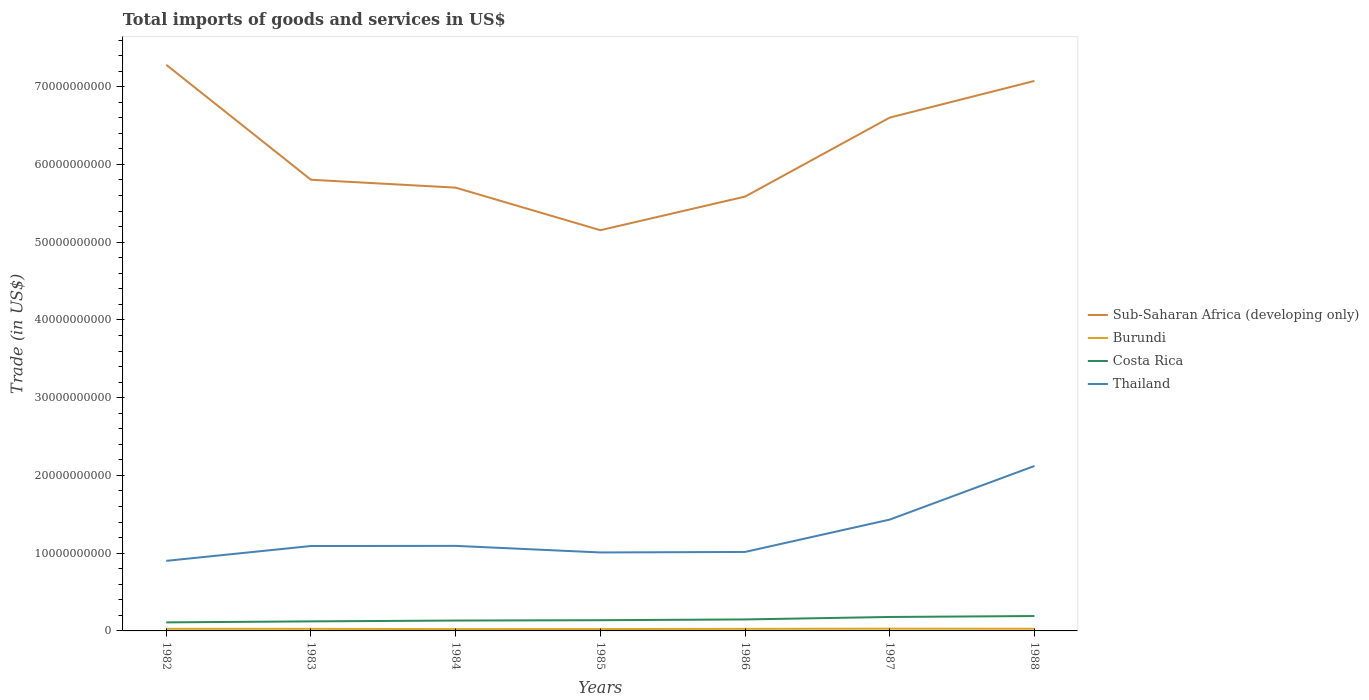How many different coloured lines are there?
Offer a terse response. 4. Is the number of lines equal to the number of legend labels?
Make the answer very short. Yes. Across all years, what is the maximum total imports of goods and services in Sub-Saharan Africa (developing only)?
Your answer should be compact. 5.15e+1. What is the total total imports of goods and services in Thailand in the graph?
Give a very brief answer. -4.23e+09. What is the difference between the highest and the second highest total imports of goods and services in Sub-Saharan Africa (developing only)?
Offer a very short reply. 2.13e+1. How many years are there in the graph?
Offer a terse response. 7. Does the graph contain grids?
Offer a very short reply. No. Where does the legend appear in the graph?
Keep it short and to the point. Center right. How are the legend labels stacked?
Your answer should be compact. Vertical. What is the title of the graph?
Give a very brief answer. Total imports of goods and services in US$. What is the label or title of the Y-axis?
Make the answer very short. Trade (in US$). What is the Trade (in US$) in Sub-Saharan Africa (developing only) in 1982?
Your response must be concise. 7.28e+1. What is the Trade (in US$) in Burundi in 1982?
Keep it short and to the point. 2.73e+08. What is the Trade (in US$) of Costa Rica in 1982?
Your answer should be compact. 1.10e+09. What is the Trade (in US$) of Thailand in 1982?
Your answer should be very brief. 9.01e+09. What is the Trade (in US$) of Sub-Saharan Africa (developing only) in 1983?
Provide a succinct answer. 5.80e+1. What is the Trade (in US$) in Burundi in 1983?
Your response must be concise. 2.68e+08. What is the Trade (in US$) in Costa Rica in 1983?
Provide a short and direct response. 1.23e+09. What is the Trade (in US$) in Thailand in 1983?
Offer a very short reply. 1.09e+1. What is the Trade (in US$) of Sub-Saharan Africa (developing only) in 1984?
Provide a short and direct response. 5.70e+1. What is the Trade (in US$) of Burundi in 1984?
Provide a succinct answer. 2.32e+08. What is the Trade (in US$) in Costa Rica in 1984?
Provide a short and direct response. 1.33e+09. What is the Trade (in US$) in Thailand in 1984?
Your response must be concise. 1.09e+1. What is the Trade (in US$) in Sub-Saharan Africa (developing only) in 1985?
Your answer should be very brief. 5.15e+1. What is the Trade (in US$) of Burundi in 1985?
Provide a succinct answer. 2.39e+08. What is the Trade (in US$) of Costa Rica in 1985?
Provide a short and direct response. 1.38e+09. What is the Trade (in US$) of Thailand in 1985?
Your answer should be compact. 1.01e+1. What is the Trade (in US$) of Sub-Saharan Africa (developing only) in 1986?
Your response must be concise. 5.59e+1. What is the Trade (in US$) in Burundi in 1986?
Keep it short and to the point. 2.68e+08. What is the Trade (in US$) of Costa Rica in 1986?
Offer a terse response. 1.48e+09. What is the Trade (in US$) of Thailand in 1986?
Offer a terse response. 1.02e+1. What is the Trade (in US$) of Sub-Saharan Africa (developing only) in 1987?
Keep it short and to the point. 6.60e+1. What is the Trade (in US$) in Burundi in 1987?
Your answer should be very brief. 2.91e+08. What is the Trade (in US$) of Costa Rica in 1987?
Your response must be concise. 1.80e+09. What is the Trade (in US$) in Thailand in 1987?
Keep it short and to the point. 1.43e+1. What is the Trade (in US$) in Sub-Saharan Africa (developing only) in 1988?
Keep it short and to the point. 7.07e+1. What is the Trade (in US$) of Burundi in 1988?
Offer a terse response. 2.81e+08. What is the Trade (in US$) in Costa Rica in 1988?
Your answer should be compact. 1.91e+09. What is the Trade (in US$) in Thailand in 1988?
Ensure brevity in your answer.  2.12e+1. Across all years, what is the maximum Trade (in US$) in Sub-Saharan Africa (developing only)?
Offer a very short reply. 7.28e+1. Across all years, what is the maximum Trade (in US$) in Burundi?
Offer a terse response. 2.91e+08. Across all years, what is the maximum Trade (in US$) in Costa Rica?
Your response must be concise. 1.91e+09. Across all years, what is the maximum Trade (in US$) of Thailand?
Offer a very short reply. 2.12e+1. Across all years, what is the minimum Trade (in US$) in Sub-Saharan Africa (developing only)?
Give a very brief answer. 5.15e+1. Across all years, what is the minimum Trade (in US$) in Burundi?
Offer a very short reply. 2.32e+08. Across all years, what is the minimum Trade (in US$) of Costa Rica?
Offer a very short reply. 1.10e+09. Across all years, what is the minimum Trade (in US$) of Thailand?
Your answer should be very brief. 9.01e+09. What is the total Trade (in US$) of Sub-Saharan Africa (developing only) in the graph?
Keep it short and to the point. 4.32e+11. What is the total Trade (in US$) in Burundi in the graph?
Ensure brevity in your answer.  1.85e+09. What is the total Trade (in US$) of Costa Rica in the graph?
Give a very brief answer. 1.02e+1. What is the total Trade (in US$) of Thailand in the graph?
Offer a very short reply. 8.67e+1. What is the difference between the Trade (in US$) in Sub-Saharan Africa (developing only) in 1982 and that in 1983?
Ensure brevity in your answer.  1.48e+1. What is the difference between the Trade (in US$) of Burundi in 1982 and that in 1983?
Give a very brief answer. 4.63e+06. What is the difference between the Trade (in US$) in Costa Rica in 1982 and that in 1983?
Provide a succinct answer. -1.28e+08. What is the difference between the Trade (in US$) of Thailand in 1982 and that in 1983?
Make the answer very short. -1.91e+09. What is the difference between the Trade (in US$) in Sub-Saharan Africa (developing only) in 1982 and that in 1984?
Your answer should be compact. 1.58e+1. What is the difference between the Trade (in US$) in Burundi in 1982 and that in 1984?
Keep it short and to the point. 4.01e+07. What is the difference between the Trade (in US$) in Costa Rica in 1982 and that in 1984?
Provide a short and direct response. -2.35e+08. What is the difference between the Trade (in US$) of Thailand in 1982 and that in 1984?
Give a very brief answer. -1.93e+09. What is the difference between the Trade (in US$) in Sub-Saharan Africa (developing only) in 1982 and that in 1985?
Provide a short and direct response. 2.13e+1. What is the difference between the Trade (in US$) in Burundi in 1982 and that in 1985?
Ensure brevity in your answer.  3.36e+07. What is the difference between the Trade (in US$) of Costa Rica in 1982 and that in 1985?
Your response must be concise. -2.79e+08. What is the difference between the Trade (in US$) of Thailand in 1982 and that in 1985?
Your answer should be compact. -1.08e+09. What is the difference between the Trade (in US$) in Sub-Saharan Africa (developing only) in 1982 and that in 1986?
Offer a terse response. 1.70e+1. What is the difference between the Trade (in US$) of Burundi in 1982 and that in 1986?
Offer a terse response. 4.46e+06. What is the difference between the Trade (in US$) in Costa Rica in 1982 and that in 1986?
Offer a terse response. -3.77e+08. What is the difference between the Trade (in US$) in Thailand in 1982 and that in 1986?
Your response must be concise. -1.15e+09. What is the difference between the Trade (in US$) in Sub-Saharan Africa (developing only) in 1982 and that in 1987?
Provide a short and direct response. 6.79e+09. What is the difference between the Trade (in US$) in Burundi in 1982 and that in 1987?
Your answer should be very brief. -1.86e+07. What is the difference between the Trade (in US$) in Costa Rica in 1982 and that in 1987?
Offer a very short reply. -6.96e+08. What is the difference between the Trade (in US$) of Thailand in 1982 and that in 1987?
Keep it short and to the point. -5.31e+09. What is the difference between the Trade (in US$) of Sub-Saharan Africa (developing only) in 1982 and that in 1988?
Your answer should be very brief. 2.08e+09. What is the difference between the Trade (in US$) of Burundi in 1982 and that in 1988?
Your answer should be compact. -8.29e+06. What is the difference between the Trade (in US$) of Costa Rica in 1982 and that in 1988?
Give a very brief answer. -8.15e+08. What is the difference between the Trade (in US$) in Thailand in 1982 and that in 1988?
Your answer should be very brief. -1.22e+1. What is the difference between the Trade (in US$) in Sub-Saharan Africa (developing only) in 1983 and that in 1984?
Ensure brevity in your answer.  1.01e+09. What is the difference between the Trade (in US$) of Burundi in 1983 and that in 1984?
Your answer should be very brief. 3.55e+07. What is the difference between the Trade (in US$) in Costa Rica in 1983 and that in 1984?
Your answer should be very brief. -1.07e+08. What is the difference between the Trade (in US$) of Thailand in 1983 and that in 1984?
Keep it short and to the point. -1.66e+07. What is the difference between the Trade (in US$) of Sub-Saharan Africa (developing only) in 1983 and that in 1985?
Ensure brevity in your answer.  6.49e+09. What is the difference between the Trade (in US$) of Burundi in 1983 and that in 1985?
Keep it short and to the point. 2.90e+07. What is the difference between the Trade (in US$) in Costa Rica in 1983 and that in 1985?
Your response must be concise. -1.51e+08. What is the difference between the Trade (in US$) in Thailand in 1983 and that in 1985?
Give a very brief answer. 8.30e+08. What is the difference between the Trade (in US$) in Sub-Saharan Africa (developing only) in 1983 and that in 1986?
Your answer should be compact. 2.17e+09. What is the difference between the Trade (in US$) in Burundi in 1983 and that in 1986?
Offer a very short reply. -1.73e+05. What is the difference between the Trade (in US$) of Costa Rica in 1983 and that in 1986?
Provide a succinct answer. -2.50e+08. What is the difference between the Trade (in US$) in Thailand in 1983 and that in 1986?
Give a very brief answer. 7.63e+08. What is the difference between the Trade (in US$) of Sub-Saharan Africa (developing only) in 1983 and that in 1987?
Provide a short and direct response. -7.99e+09. What is the difference between the Trade (in US$) in Burundi in 1983 and that in 1987?
Keep it short and to the point. -2.32e+07. What is the difference between the Trade (in US$) in Costa Rica in 1983 and that in 1987?
Your answer should be very brief. -5.68e+08. What is the difference between the Trade (in US$) in Thailand in 1983 and that in 1987?
Keep it short and to the point. -3.40e+09. What is the difference between the Trade (in US$) in Sub-Saharan Africa (developing only) in 1983 and that in 1988?
Your answer should be compact. -1.27e+1. What is the difference between the Trade (in US$) in Burundi in 1983 and that in 1988?
Your response must be concise. -1.29e+07. What is the difference between the Trade (in US$) of Costa Rica in 1983 and that in 1988?
Offer a very short reply. -6.88e+08. What is the difference between the Trade (in US$) in Thailand in 1983 and that in 1988?
Make the answer very short. -1.03e+1. What is the difference between the Trade (in US$) of Sub-Saharan Africa (developing only) in 1984 and that in 1985?
Make the answer very short. 5.47e+09. What is the difference between the Trade (in US$) of Burundi in 1984 and that in 1985?
Offer a terse response. -6.55e+06. What is the difference between the Trade (in US$) in Costa Rica in 1984 and that in 1985?
Your response must be concise. -4.40e+07. What is the difference between the Trade (in US$) of Thailand in 1984 and that in 1985?
Provide a short and direct response. 8.46e+08. What is the difference between the Trade (in US$) of Sub-Saharan Africa (developing only) in 1984 and that in 1986?
Give a very brief answer. 1.15e+09. What is the difference between the Trade (in US$) in Burundi in 1984 and that in 1986?
Ensure brevity in your answer.  -3.57e+07. What is the difference between the Trade (in US$) of Costa Rica in 1984 and that in 1986?
Give a very brief answer. -1.43e+08. What is the difference between the Trade (in US$) of Thailand in 1984 and that in 1986?
Ensure brevity in your answer.  7.80e+08. What is the difference between the Trade (in US$) of Sub-Saharan Africa (developing only) in 1984 and that in 1987?
Your answer should be very brief. -9.01e+09. What is the difference between the Trade (in US$) of Burundi in 1984 and that in 1987?
Ensure brevity in your answer.  -5.87e+07. What is the difference between the Trade (in US$) in Costa Rica in 1984 and that in 1987?
Give a very brief answer. -4.62e+08. What is the difference between the Trade (in US$) of Thailand in 1984 and that in 1987?
Your answer should be compact. -3.38e+09. What is the difference between the Trade (in US$) in Sub-Saharan Africa (developing only) in 1984 and that in 1988?
Your response must be concise. -1.37e+1. What is the difference between the Trade (in US$) in Burundi in 1984 and that in 1988?
Your response must be concise. -4.84e+07. What is the difference between the Trade (in US$) in Costa Rica in 1984 and that in 1988?
Provide a succinct answer. -5.81e+08. What is the difference between the Trade (in US$) in Thailand in 1984 and that in 1988?
Ensure brevity in your answer.  -1.03e+1. What is the difference between the Trade (in US$) in Sub-Saharan Africa (developing only) in 1985 and that in 1986?
Provide a succinct answer. -4.32e+09. What is the difference between the Trade (in US$) of Burundi in 1985 and that in 1986?
Offer a terse response. -2.91e+07. What is the difference between the Trade (in US$) of Costa Rica in 1985 and that in 1986?
Make the answer very short. -9.89e+07. What is the difference between the Trade (in US$) in Thailand in 1985 and that in 1986?
Make the answer very short. -6.60e+07. What is the difference between the Trade (in US$) in Sub-Saharan Africa (developing only) in 1985 and that in 1987?
Your answer should be compact. -1.45e+1. What is the difference between the Trade (in US$) of Burundi in 1985 and that in 1987?
Your answer should be compact. -5.22e+07. What is the difference between the Trade (in US$) in Costa Rica in 1985 and that in 1987?
Offer a terse response. -4.18e+08. What is the difference between the Trade (in US$) of Thailand in 1985 and that in 1987?
Make the answer very short. -4.23e+09. What is the difference between the Trade (in US$) in Sub-Saharan Africa (developing only) in 1985 and that in 1988?
Your response must be concise. -1.92e+1. What is the difference between the Trade (in US$) in Burundi in 1985 and that in 1988?
Your response must be concise. -4.19e+07. What is the difference between the Trade (in US$) in Costa Rica in 1985 and that in 1988?
Your answer should be compact. -5.37e+08. What is the difference between the Trade (in US$) in Thailand in 1985 and that in 1988?
Give a very brief answer. -1.11e+1. What is the difference between the Trade (in US$) of Sub-Saharan Africa (developing only) in 1986 and that in 1987?
Offer a terse response. -1.02e+1. What is the difference between the Trade (in US$) of Burundi in 1986 and that in 1987?
Provide a succinct answer. -2.31e+07. What is the difference between the Trade (in US$) in Costa Rica in 1986 and that in 1987?
Provide a short and direct response. -3.19e+08. What is the difference between the Trade (in US$) of Thailand in 1986 and that in 1987?
Offer a very short reply. -4.16e+09. What is the difference between the Trade (in US$) in Sub-Saharan Africa (developing only) in 1986 and that in 1988?
Provide a short and direct response. -1.49e+1. What is the difference between the Trade (in US$) of Burundi in 1986 and that in 1988?
Your response must be concise. -1.27e+07. What is the difference between the Trade (in US$) of Costa Rica in 1986 and that in 1988?
Offer a very short reply. -4.38e+08. What is the difference between the Trade (in US$) in Thailand in 1986 and that in 1988?
Your response must be concise. -1.11e+1. What is the difference between the Trade (in US$) of Sub-Saharan Africa (developing only) in 1987 and that in 1988?
Your response must be concise. -4.72e+09. What is the difference between the Trade (in US$) in Burundi in 1987 and that in 1988?
Offer a terse response. 1.03e+07. What is the difference between the Trade (in US$) of Costa Rica in 1987 and that in 1988?
Give a very brief answer. -1.19e+08. What is the difference between the Trade (in US$) in Thailand in 1987 and that in 1988?
Keep it short and to the point. -6.90e+09. What is the difference between the Trade (in US$) in Sub-Saharan Africa (developing only) in 1982 and the Trade (in US$) in Burundi in 1983?
Your answer should be compact. 7.25e+1. What is the difference between the Trade (in US$) in Sub-Saharan Africa (developing only) in 1982 and the Trade (in US$) in Costa Rica in 1983?
Provide a succinct answer. 7.16e+1. What is the difference between the Trade (in US$) in Sub-Saharan Africa (developing only) in 1982 and the Trade (in US$) in Thailand in 1983?
Your response must be concise. 6.19e+1. What is the difference between the Trade (in US$) of Burundi in 1982 and the Trade (in US$) of Costa Rica in 1983?
Your answer should be very brief. -9.54e+08. What is the difference between the Trade (in US$) of Burundi in 1982 and the Trade (in US$) of Thailand in 1983?
Offer a terse response. -1.06e+1. What is the difference between the Trade (in US$) in Costa Rica in 1982 and the Trade (in US$) in Thailand in 1983?
Your answer should be compact. -9.82e+09. What is the difference between the Trade (in US$) of Sub-Saharan Africa (developing only) in 1982 and the Trade (in US$) of Burundi in 1984?
Your answer should be compact. 7.26e+1. What is the difference between the Trade (in US$) of Sub-Saharan Africa (developing only) in 1982 and the Trade (in US$) of Costa Rica in 1984?
Your answer should be very brief. 7.15e+1. What is the difference between the Trade (in US$) of Sub-Saharan Africa (developing only) in 1982 and the Trade (in US$) of Thailand in 1984?
Keep it short and to the point. 6.19e+1. What is the difference between the Trade (in US$) in Burundi in 1982 and the Trade (in US$) in Costa Rica in 1984?
Provide a short and direct response. -1.06e+09. What is the difference between the Trade (in US$) of Burundi in 1982 and the Trade (in US$) of Thailand in 1984?
Your answer should be very brief. -1.07e+1. What is the difference between the Trade (in US$) in Costa Rica in 1982 and the Trade (in US$) in Thailand in 1984?
Provide a succinct answer. -9.84e+09. What is the difference between the Trade (in US$) of Sub-Saharan Africa (developing only) in 1982 and the Trade (in US$) of Burundi in 1985?
Make the answer very short. 7.26e+1. What is the difference between the Trade (in US$) in Sub-Saharan Africa (developing only) in 1982 and the Trade (in US$) in Costa Rica in 1985?
Give a very brief answer. 7.14e+1. What is the difference between the Trade (in US$) in Sub-Saharan Africa (developing only) in 1982 and the Trade (in US$) in Thailand in 1985?
Ensure brevity in your answer.  6.27e+1. What is the difference between the Trade (in US$) in Burundi in 1982 and the Trade (in US$) in Costa Rica in 1985?
Offer a very short reply. -1.10e+09. What is the difference between the Trade (in US$) of Burundi in 1982 and the Trade (in US$) of Thailand in 1985?
Offer a terse response. -9.82e+09. What is the difference between the Trade (in US$) of Costa Rica in 1982 and the Trade (in US$) of Thailand in 1985?
Offer a very short reply. -8.99e+09. What is the difference between the Trade (in US$) of Sub-Saharan Africa (developing only) in 1982 and the Trade (in US$) of Burundi in 1986?
Provide a short and direct response. 7.25e+1. What is the difference between the Trade (in US$) of Sub-Saharan Africa (developing only) in 1982 and the Trade (in US$) of Costa Rica in 1986?
Your response must be concise. 7.13e+1. What is the difference between the Trade (in US$) in Sub-Saharan Africa (developing only) in 1982 and the Trade (in US$) in Thailand in 1986?
Offer a very short reply. 6.27e+1. What is the difference between the Trade (in US$) of Burundi in 1982 and the Trade (in US$) of Costa Rica in 1986?
Provide a succinct answer. -1.20e+09. What is the difference between the Trade (in US$) in Burundi in 1982 and the Trade (in US$) in Thailand in 1986?
Give a very brief answer. -9.88e+09. What is the difference between the Trade (in US$) in Costa Rica in 1982 and the Trade (in US$) in Thailand in 1986?
Your answer should be very brief. -9.06e+09. What is the difference between the Trade (in US$) in Sub-Saharan Africa (developing only) in 1982 and the Trade (in US$) in Burundi in 1987?
Your response must be concise. 7.25e+1. What is the difference between the Trade (in US$) in Sub-Saharan Africa (developing only) in 1982 and the Trade (in US$) in Costa Rica in 1987?
Your answer should be very brief. 7.10e+1. What is the difference between the Trade (in US$) in Sub-Saharan Africa (developing only) in 1982 and the Trade (in US$) in Thailand in 1987?
Ensure brevity in your answer.  5.85e+1. What is the difference between the Trade (in US$) in Burundi in 1982 and the Trade (in US$) in Costa Rica in 1987?
Offer a terse response. -1.52e+09. What is the difference between the Trade (in US$) in Burundi in 1982 and the Trade (in US$) in Thailand in 1987?
Your answer should be very brief. -1.40e+1. What is the difference between the Trade (in US$) in Costa Rica in 1982 and the Trade (in US$) in Thailand in 1987?
Offer a terse response. -1.32e+1. What is the difference between the Trade (in US$) in Sub-Saharan Africa (developing only) in 1982 and the Trade (in US$) in Burundi in 1988?
Your answer should be very brief. 7.25e+1. What is the difference between the Trade (in US$) in Sub-Saharan Africa (developing only) in 1982 and the Trade (in US$) in Costa Rica in 1988?
Keep it short and to the point. 7.09e+1. What is the difference between the Trade (in US$) in Sub-Saharan Africa (developing only) in 1982 and the Trade (in US$) in Thailand in 1988?
Offer a very short reply. 5.16e+1. What is the difference between the Trade (in US$) in Burundi in 1982 and the Trade (in US$) in Costa Rica in 1988?
Provide a succinct answer. -1.64e+09. What is the difference between the Trade (in US$) in Burundi in 1982 and the Trade (in US$) in Thailand in 1988?
Give a very brief answer. -2.09e+1. What is the difference between the Trade (in US$) in Costa Rica in 1982 and the Trade (in US$) in Thailand in 1988?
Keep it short and to the point. -2.01e+1. What is the difference between the Trade (in US$) of Sub-Saharan Africa (developing only) in 1983 and the Trade (in US$) of Burundi in 1984?
Your response must be concise. 5.78e+1. What is the difference between the Trade (in US$) of Sub-Saharan Africa (developing only) in 1983 and the Trade (in US$) of Costa Rica in 1984?
Offer a terse response. 5.67e+1. What is the difference between the Trade (in US$) in Sub-Saharan Africa (developing only) in 1983 and the Trade (in US$) in Thailand in 1984?
Give a very brief answer. 4.71e+1. What is the difference between the Trade (in US$) in Burundi in 1983 and the Trade (in US$) in Costa Rica in 1984?
Offer a terse response. -1.07e+09. What is the difference between the Trade (in US$) in Burundi in 1983 and the Trade (in US$) in Thailand in 1984?
Provide a short and direct response. -1.07e+1. What is the difference between the Trade (in US$) of Costa Rica in 1983 and the Trade (in US$) of Thailand in 1984?
Your answer should be very brief. -9.71e+09. What is the difference between the Trade (in US$) of Sub-Saharan Africa (developing only) in 1983 and the Trade (in US$) of Burundi in 1985?
Provide a succinct answer. 5.78e+1. What is the difference between the Trade (in US$) of Sub-Saharan Africa (developing only) in 1983 and the Trade (in US$) of Costa Rica in 1985?
Your response must be concise. 5.66e+1. What is the difference between the Trade (in US$) of Sub-Saharan Africa (developing only) in 1983 and the Trade (in US$) of Thailand in 1985?
Give a very brief answer. 4.79e+1. What is the difference between the Trade (in US$) of Burundi in 1983 and the Trade (in US$) of Costa Rica in 1985?
Give a very brief answer. -1.11e+09. What is the difference between the Trade (in US$) of Burundi in 1983 and the Trade (in US$) of Thailand in 1985?
Provide a short and direct response. -9.82e+09. What is the difference between the Trade (in US$) in Costa Rica in 1983 and the Trade (in US$) in Thailand in 1985?
Your answer should be very brief. -8.86e+09. What is the difference between the Trade (in US$) in Sub-Saharan Africa (developing only) in 1983 and the Trade (in US$) in Burundi in 1986?
Provide a succinct answer. 5.78e+1. What is the difference between the Trade (in US$) in Sub-Saharan Africa (developing only) in 1983 and the Trade (in US$) in Costa Rica in 1986?
Your answer should be very brief. 5.66e+1. What is the difference between the Trade (in US$) of Sub-Saharan Africa (developing only) in 1983 and the Trade (in US$) of Thailand in 1986?
Offer a very short reply. 4.79e+1. What is the difference between the Trade (in US$) in Burundi in 1983 and the Trade (in US$) in Costa Rica in 1986?
Provide a short and direct response. -1.21e+09. What is the difference between the Trade (in US$) of Burundi in 1983 and the Trade (in US$) of Thailand in 1986?
Ensure brevity in your answer.  -9.89e+09. What is the difference between the Trade (in US$) in Costa Rica in 1983 and the Trade (in US$) in Thailand in 1986?
Ensure brevity in your answer.  -8.93e+09. What is the difference between the Trade (in US$) of Sub-Saharan Africa (developing only) in 1983 and the Trade (in US$) of Burundi in 1987?
Provide a short and direct response. 5.77e+1. What is the difference between the Trade (in US$) in Sub-Saharan Africa (developing only) in 1983 and the Trade (in US$) in Costa Rica in 1987?
Offer a terse response. 5.62e+1. What is the difference between the Trade (in US$) in Sub-Saharan Africa (developing only) in 1983 and the Trade (in US$) in Thailand in 1987?
Provide a succinct answer. 4.37e+1. What is the difference between the Trade (in US$) of Burundi in 1983 and the Trade (in US$) of Costa Rica in 1987?
Offer a very short reply. -1.53e+09. What is the difference between the Trade (in US$) of Burundi in 1983 and the Trade (in US$) of Thailand in 1987?
Ensure brevity in your answer.  -1.41e+1. What is the difference between the Trade (in US$) of Costa Rica in 1983 and the Trade (in US$) of Thailand in 1987?
Give a very brief answer. -1.31e+1. What is the difference between the Trade (in US$) of Sub-Saharan Africa (developing only) in 1983 and the Trade (in US$) of Burundi in 1988?
Your answer should be very brief. 5.77e+1. What is the difference between the Trade (in US$) of Sub-Saharan Africa (developing only) in 1983 and the Trade (in US$) of Costa Rica in 1988?
Ensure brevity in your answer.  5.61e+1. What is the difference between the Trade (in US$) of Sub-Saharan Africa (developing only) in 1983 and the Trade (in US$) of Thailand in 1988?
Give a very brief answer. 3.68e+1. What is the difference between the Trade (in US$) of Burundi in 1983 and the Trade (in US$) of Costa Rica in 1988?
Give a very brief answer. -1.65e+09. What is the difference between the Trade (in US$) of Burundi in 1983 and the Trade (in US$) of Thailand in 1988?
Keep it short and to the point. -2.09e+1. What is the difference between the Trade (in US$) in Costa Rica in 1983 and the Trade (in US$) in Thailand in 1988?
Provide a short and direct response. -2.00e+1. What is the difference between the Trade (in US$) in Sub-Saharan Africa (developing only) in 1984 and the Trade (in US$) in Burundi in 1985?
Ensure brevity in your answer.  5.68e+1. What is the difference between the Trade (in US$) in Sub-Saharan Africa (developing only) in 1984 and the Trade (in US$) in Costa Rica in 1985?
Keep it short and to the point. 5.56e+1. What is the difference between the Trade (in US$) of Sub-Saharan Africa (developing only) in 1984 and the Trade (in US$) of Thailand in 1985?
Offer a very short reply. 4.69e+1. What is the difference between the Trade (in US$) of Burundi in 1984 and the Trade (in US$) of Costa Rica in 1985?
Keep it short and to the point. -1.15e+09. What is the difference between the Trade (in US$) of Burundi in 1984 and the Trade (in US$) of Thailand in 1985?
Give a very brief answer. -9.86e+09. What is the difference between the Trade (in US$) in Costa Rica in 1984 and the Trade (in US$) in Thailand in 1985?
Offer a very short reply. -8.76e+09. What is the difference between the Trade (in US$) in Sub-Saharan Africa (developing only) in 1984 and the Trade (in US$) in Burundi in 1986?
Offer a terse response. 5.67e+1. What is the difference between the Trade (in US$) in Sub-Saharan Africa (developing only) in 1984 and the Trade (in US$) in Costa Rica in 1986?
Your response must be concise. 5.55e+1. What is the difference between the Trade (in US$) in Sub-Saharan Africa (developing only) in 1984 and the Trade (in US$) in Thailand in 1986?
Your answer should be very brief. 4.69e+1. What is the difference between the Trade (in US$) in Burundi in 1984 and the Trade (in US$) in Costa Rica in 1986?
Offer a very short reply. -1.24e+09. What is the difference between the Trade (in US$) of Burundi in 1984 and the Trade (in US$) of Thailand in 1986?
Your answer should be very brief. -9.93e+09. What is the difference between the Trade (in US$) in Costa Rica in 1984 and the Trade (in US$) in Thailand in 1986?
Offer a very short reply. -8.82e+09. What is the difference between the Trade (in US$) in Sub-Saharan Africa (developing only) in 1984 and the Trade (in US$) in Burundi in 1987?
Make the answer very short. 5.67e+1. What is the difference between the Trade (in US$) in Sub-Saharan Africa (developing only) in 1984 and the Trade (in US$) in Costa Rica in 1987?
Give a very brief answer. 5.52e+1. What is the difference between the Trade (in US$) of Sub-Saharan Africa (developing only) in 1984 and the Trade (in US$) of Thailand in 1987?
Provide a succinct answer. 4.27e+1. What is the difference between the Trade (in US$) in Burundi in 1984 and the Trade (in US$) in Costa Rica in 1987?
Your answer should be very brief. -1.56e+09. What is the difference between the Trade (in US$) in Burundi in 1984 and the Trade (in US$) in Thailand in 1987?
Provide a succinct answer. -1.41e+1. What is the difference between the Trade (in US$) in Costa Rica in 1984 and the Trade (in US$) in Thailand in 1987?
Offer a terse response. -1.30e+1. What is the difference between the Trade (in US$) in Sub-Saharan Africa (developing only) in 1984 and the Trade (in US$) in Burundi in 1988?
Provide a succinct answer. 5.67e+1. What is the difference between the Trade (in US$) in Sub-Saharan Africa (developing only) in 1984 and the Trade (in US$) in Costa Rica in 1988?
Your answer should be compact. 5.51e+1. What is the difference between the Trade (in US$) of Sub-Saharan Africa (developing only) in 1984 and the Trade (in US$) of Thailand in 1988?
Your answer should be very brief. 3.58e+1. What is the difference between the Trade (in US$) of Burundi in 1984 and the Trade (in US$) of Costa Rica in 1988?
Offer a very short reply. -1.68e+09. What is the difference between the Trade (in US$) in Burundi in 1984 and the Trade (in US$) in Thailand in 1988?
Give a very brief answer. -2.10e+1. What is the difference between the Trade (in US$) of Costa Rica in 1984 and the Trade (in US$) of Thailand in 1988?
Offer a terse response. -1.99e+1. What is the difference between the Trade (in US$) in Sub-Saharan Africa (developing only) in 1985 and the Trade (in US$) in Burundi in 1986?
Keep it short and to the point. 5.13e+1. What is the difference between the Trade (in US$) in Sub-Saharan Africa (developing only) in 1985 and the Trade (in US$) in Costa Rica in 1986?
Your answer should be compact. 5.01e+1. What is the difference between the Trade (in US$) of Sub-Saharan Africa (developing only) in 1985 and the Trade (in US$) of Thailand in 1986?
Your answer should be compact. 4.14e+1. What is the difference between the Trade (in US$) in Burundi in 1985 and the Trade (in US$) in Costa Rica in 1986?
Provide a short and direct response. -1.24e+09. What is the difference between the Trade (in US$) of Burundi in 1985 and the Trade (in US$) of Thailand in 1986?
Provide a short and direct response. -9.92e+09. What is the difference between the Trade (in US$) in Costa Rica in 1985 and the Trade (in US$) in Thailand in 1986?
Your answer should be very brief. -8.78e+09. What is the difference between the Trade (in US$) in Sub-Saharan Africa (developing only) in 1985 and the Trade (in US$) in Burundi in 1987?
Offer a very short reply. 5.12e+1. What is the difference between the Trade (in US$) in Sub-Saharan Africa (developing only) in 1985 and the Trade (in US$) in Costa Rica in 1987?
Make the answer very short. 4.97e+1. What is the difference between the Trade (in US$) of Sub-Saharan Africa (developing only) in 1985 and the Trade (in US$) of Thailand in 1987?
Your answer should be compact. 3.72e+1. What is the difference between the Trade (in US$) of Burundi in 1985 and the Trade (in US$) of Costa Rica in 1987?
Offer a terse response. -1.56e+09. What is the difference between the Trade (in US$) in Burundi in 1985 and the Trade (in US$) in Thailand in 1987?
Make the answer very short. -1.41e+1. What is the difference between the Trade (in US$) in Costa Rica in 1985 and the Trade (in US$) in Thailand in 1987?
Ensure brevity in your answer.  -1.29e+1. What is the difference between the Trade (in US$) of Sub-Saharan Africa (developing only) in 1985 and the Trade (in US$) of Burundi in 1988?
Ensure brevity in your answer.  5.13e+1. What is the difference between the Trade (in US$) of Sub-Saharan Africa (developing only) in 1985 and the Trade (in US$) of Costa Rica in 1988?
Provide a short and direct response. 4.96e+1. What is the difference between the Trade (in US$) in Sub-Saharan Africa (developing only) in 1985 and the Trade (in US$) in Thailand in 1988?
Provide a short and direct response. 3.03e+1. What is the difference between the Trade (in US$) in Burundi in 1985 and the Trade (in US$) in Costa Rica in 1988?
Your answer should be very brief. -1.68e+09. What is the difference between the Trade (in US$) in Burundi in 1985 and the Trade (in US$) in Thailand in 1988?
Your answer should be compact. -2.10e+1. What is the difference between the Trade (in US$) in Costa Rica in 1985 and the Trade (in US$) in Thailand in 1988?
Ensure brevity in your answer.  -1.98e+1. What is the difference between the Trade (in US$) of Sub-Saharan Africa (developing only) in 1986 and the Trade (in US$) of Burundi in 1987?
Your answer should be compact. 5.56e+1. What is the difference between the Trade (in US$) of Sub-Saharan Africa (developing only) in 1986 and the Trade (in US$) of Costa Rica in 1987?
Give a very brief answer. 5.41e+1. What is the difference between the Trade (in US$) of Sub-Saharan Africa (developing only) in 1986 and the Trade (in US$) of Thailand in 1987?
Your answer should be compact. 4.15e+1. What is the difference between the Trade (in US$) of Burundi in 1986 and the Trade (in US$) of Costa Rica in 1987?
Ensure brevity in your answer.  -1.53e+09. What is the difference between the Trade (in US$) of Burundi in 1986 and the Trade (in US$) of Thailand in 1987?
Make the answer very short. -1.41e+1. What is the difference between the Trade (in US$) of Costa Rica in 1986 and the Trade (in US$) of Thailand in 1987?
Offer a very short reply. -1.28e+1. What is the difference between the Trade (in US$) in Sub-Saharan Africa (developing only) in 1986 and the Trade (in US$) in Burundi in 1988?
Provide a short and direct response. 5.56e+1. What is the difference between the Trade (in US$) of Sub-Saharan Africa (developing only) in 1986 and the Trade (in US$) of Costa Rica in 1988?
Ensure brevity in your answer.  5.39e+1. What is the difference between the Trade (in US$) in Sub-Saharan Africa (developing only) in 1986 and the Trade (in US$) in Thailand in 1988?
Provide a short and direct response. 3.46e+1. What is the difference between the Trade (in US$) in Burundi in 1986 and the Trade (in US$) in Costa Rica in 1988?
Provide a succinct answer. -1.65e+09. What is the difference between the Trade (in US$) in Burundi in 1986 and the Trade (in US$) in Thailand in 1988?
Provide a short and direct response. -2.09e+1. What is the difference between the Trade (in US$) of Costa Rica in 1986 and the Trade (in US$) of Thailand in 1988?
Offer a very short reply. -1.97e+1. What is the difference between the Trade (in US$) in Sub-Saharan Africa (developing only) in 1987 and the Trade (in US$) in Burundi in 1988?
Offer a very short reply. 6.57e+1. What is the difference between the Trade (in US$) in Sub-Saharan Africa (developing only) in 1987 and the Trade (in US$) in Costa Rica in 1988?
Your response must be concise. 6.41e+1. What is the difference between the Trade (in US$) in Sub-Saharan Africa (developing only) in 1987 and the Trade (in US$) in Thailand in 1988?
Provide a short and direct response. 4.48e+1. What is the difference between the Trade (in US$) of Burundi in 1987 and the Trade (in US$) of Costa Rica in 1988?
Offer a very short reply. -1.62e+09. What is the difference between the Trade (in US$) of Burundi in 1987 and the Trade (in US$) of Thailand in 1988?
Your response must be concise. -2.09e+1. What is the difference between the Trade (in US$) of Costa Rica in 1987 and the Trade (in US$) of Thailand in 1988?
Give a very brief answer. -1.94e+1. What is the average Trade (in US$) of Sub-Saharan Africa (developing only) per year?
Your answer should be compact. 6.17e+1. What is the average Trade (in US$) in Burundi per year?
Provide a short and direct response. 2.65e+08. What is the average Trade (in US$) of Costa Rica per year?
Keep it short and to the point. 1.46e+09. What is the average Trade (in US$) in Thailand per year?
Provide a succinct answer. 1.24e+1. In the year 1982, what is the difference between the Trade (in US$) in Sub-Saharan Africa (developing only) and Trade (in US$) in Burundi?
Provide a short and direct response. 7.25e+1. In the year 1982, what is the difference between the Trade (in US$) in Sub-Saharan Africa (developing only) and Trade (in US$) in Costa Rica?
Make the answer very short. 7.17e+1. In the year 1982, what is the difference between the Trade (in US$) of Sub-Saharan Africa (developing only) and Trade (in US$) of Thailand?
Offer a very short reply. 6.38e+1. In the year 1982, what is the difference between the Trade (in US$) in Burundi and Trade (in US$) in Costa Rica?
Make the answer very short. -8.26e+08. In the year 1982, what is the difference between the Trade (in US$) of Burundi and Trade (in US$) of Thailand?
Give a very brief answer. -8.74e+09. In the year 1982, what is the difference between the Trade (in US$) in Costa Rica and Trade (in US$) in Thailand?
Provide a succinct answer. -7.91e+09. In the year 1983, what is the difference between the Trade (in US$) in Sub-Saharan Africa (developing only) and Trade (in US$) in Burundi?
Offer a very short reply. 5.78e+1. In the year 1983, what is the difference between the Trade (in US$) in Sub-Saharan Africa (developing only) and Trade (in US$) in Costa Rica?
Your answer should be very brief. 5.68e+1. In the year 1983, what is the difference between the Trade (in US$) of Sub-Saharan Africa (developing only) and Trade (in US$) of Thailand?
Ensure brevity in your answer.  4.71e+1. In the year 1983, what is the difference between the Trade (in US$) of Burundi and Trade (in US$) of Costa Rica?
Your answer should be very brief. -9.59e+08. In the year 1983, what is the difference between the Trade (in US$) in Burundi and Trade (in US$) in Thailand?
Keep it short and to the point. -1.07e+1. In the year 1983, what is the difference between the Trade (in US$) in Costa Rica and Trade (in US$) in Thailand?
Give a very brief answer. -9.69e+09. In the year 1984, what is the difference between the Trade (in US$) in Sub-Saharan Africa (developing only) and Trade (in US$) in Burundi?
Provide a succinct answer. 5.68e+1. In the year 1984, what is the difference between the Trade (in US$) in Sub-Saharan Africa (developing only) and Trade (in US$) in Costa Rica?
Offer a terse response. 5.57e+1. In the year 1984, what is the difference between the Trade (in US$) of Sub-Saharan Africa (developing only) and Trade (in US$) of Thailand?
Make the answer very short. 4.61e+1. In the year 1984, what is the difference between the Trade (in US$) of Burundi and Trade (in US$) of Costa Rica?
Provide a succinct answer. -1.10e+09. In the year 1984, what is the difference between the Trade (in US$) in Burundi and Trade (in US$) in Thailand?
Your answer should be compact. -1.07e+1. In the year 1984, what is the difference between the Trade (in US$) of Costa Rica and Trade (in US$) of Thailand?
Offer a very short reply. -9.60e+09. In the year 1985, what is the difference between the Trade (in US$) in Sub-Saharan Africa (developing only) and Trade (in US$) in Burundi?
Your response must be concise. 5.13e+1. In the year 1985, what is the difference between the Trade (in US$) of Sub-Saharan Africa (developing only) and Trade (in US$) of Costa Rica?
Keep it short and to the point. 5.02e+1. In the year 1985, what is the difference between the Trade (in US$) of Sub-Saharan Africa (developing only) and Trade (in US$) of Thailand?
Your answer should be very brief. 4.14e+1. In the year 1985, what is the difference between the Trade (in US$) of Burundi and Trade (in US$) of Costa Rica?
Offer a very short reply. -1.14e+09. In the year 1985, what is the difference between the Trade (in US$) in Burundi and Trade (in US$) in Thailand?
Offer a terse response. -9.85e+09. In the year 1985, what is the difference between the Trade (in US$) of Costa Rica and Trade (in US$) of Thailand?
Your answer should be compact. -8.71e+09. In the year 1986, what is the difference between the Trade (in US$) of Sub-Saharan Africa (developing only) and Trade (in US$) of Burundi?
Your answer should be very brief. 5.56e+1. In the year 1986, what is the difference between the Trade (in US$) in Sub-Saharan Africa (developing only) and Trade (in US$) in Costa Rica?
Your answer should be very brief. 5.44e+1. In the year 1986, what is the difference between the Trade (in US$) of Sub-Saharan Africa (developing only) and Trade (in US$) of Thailand?
Your response must be concise. 4.57e+1. In the year 1986, what is the difference between the Trade (in US$) of Burundi and Trade (in US$) of Costa Rica?
Your response must be concise. -1.21e+09. In the year 1986, what is the difference between the Trade (in US$) in Burundi and Trade (in US$) in Thailand?
Make the answer very short. -9.89e+09. In the year 1986, what is the difference between the Trade (in US$) in Costa Rica and Trade (in US$) in Thailand?
Keep it short and to the point. -8.68e+09. In the year 1987, what is the difference between the Trade (in US$) in Sub-Saharan Africa (developing only) and Trade (in US$) in Burundi?
Offer a very short reply. 6.57e+1. In the year 1987, what is the difference between the Trade (in US$) in Sub-Saharan Africa (developing only) and Trade (in US$) in Costa Rica?
Offer a terse response. 6.42e+1. In the year 1987, what is the difference between the Trade (in US$) of Sub-Saharan Africa (developing only) and Trade (in US$) of Thailand?
Your answer should be very brief. 5.17e+1. In the year 1987, what is the difference between the Trade (in US$) of Burundi and Trade (in US$) of Costa Rica?
Give a very brief answer. -1.50e+09. In the year 1987, what is the difference between the Trade (in US$) of Burundi and Trade (in US$) of Thailand?
Your response must be concise. -1.40e+1. In the year 1987, what is the difference between the Trade (in US$) of Costa Rica and Trade (in US$) of Thailand?
Ensure brevity in your answer.  -1.25e+1. In the year 1988, what is the difference between the Trade (in US$) in Sub-Saharan Africa (developing only) and Trade (in US$) in Burundi?
Your answer should be compact. 7.05e+1. In the year 1988, what is the difference between the Trade (in US$) in Sub-Saharan Africa (developing only) and Trade (in US$) in Costa Rica?
Your answer should be compact. 6.88e+1. In the year 1988, what is the difference between the Trade (in US$) in Sub-Saharan Africa (developing only) and Trade (in US$) in Thailand?
Keep it short and to the point. 4.95e+1. In the year 1988, what is the difference between the Trade (in US$) in Burundi and Trade (in US$) in Costa Rica?
Your answer should be compact. -1.63e+09. In the year 1988, what is the difference between the Trade (in US$) of Burundi and Trade (in US$) of Thailand?
Provide a succinct answer. -2.09e+1. In the year 1988, what is the difference between the Trade (in US$) of Costa Rica and Trade (in US$) of Thailand?
Offer a very short reply. -1.93e+1. What is the ratio of the Trade (in US$) of Sub-Saharan Africa (developing only) in 1982 to that in 1983?
Ensure brevity in your answer.  1.25. What is the ratio of the Trade (in US$) in Burundi in 1982 to that in 1983?
Offer a very short reply. 1.02. What is the ratio of the Trade (in US$) of Costa Rica in 1982 to that in 1983?
Your answer should be compact. 0.9. What is the ratio of the Trade (in US$) in Thailand in 1982 to that in 1983?
Give a very brief answer. 0.83. What is the ratio of the Trade (in US$) in Sub-Saharan Africa (developing only) in 1982 to that in 1984?
Give a very brief answer. 1.28. What is the ratio of the Trade (in US$) in Burundi in 1982 to that in 1984?
Offer a terse response. 1.17. What is the ratio of the Trade (in US$) in Costa Rica in 1982 to that in 1984?
Provide a succinct answer. 0.82. What is the ratio of the Trade (in US$) of Thailand in 1982 to that in 1984?
Give a very brief answer. 0.82. What is the ratio of the Trade (in US$) in Sub-Saharan Africa (developing only) in 1982 to that in 1985?
Keep it short and to the point. 1.41. What is the ratio of the Trade (in US$) in Burundi in 1982 to that in 1985?
Ensure brevity in your answer.  1.14. What is the ratio of the Trade (in US$) of Costa Rica in 1982 to that in 1985?
Offer a terse response. 0.8. What is the ratio of the Trade (in US$) of Thailand in 1982 to that in 1985?
Offer a very short reply. 0.89. What is the ratio of the Trade (in US$) of Sub-Saharan Africa (developing only) in 1982 to that in 1986?
Your response must be concise. 1.3. What is the ratio of the Trade (in US$) of Burundi in 1982 to that in 1986?
Ensure brevity in your answer.  1.02. What is the ratio of the Trade (in US$) of Costa Rica in 1982 to that in 1986?
Your answer should be very brief. 0.74. What is the ratio of the Trade (in US$) in Thailand in 1982 to that in 1986?
Keep it short and to the point. 0.89. What is the ratio of the Trade (in US$) of Sub-Saharan Africa (developing only) in 1982 to that in 1987?
Your answer should be compact. 1.1. What is the ratio of the Trade (in US$) of Burundi in 1982 to that in 1987?
Offer a very short reply. 0.94. What is the ratio of the Trade (in US$) of Costa Rica in 1982 to that in 1987?
Make the answer very short. 0.61. What is the ratio of the Trade (in US$) in Thailand in 1982 to that in 1987?
Offer a very short reply. 0.63. What is the ratio of the Trade (in US$) in Sub-Saharan Africa (developing only) in 1982 to that in 1988?
Your response must be concise. 1.03. What is the ratio of the Trade (in US$) of Burundi in 1982 to that in 1988?
Ensure brevity in your answer.  0.97. What is the ratio of the Trade (in US$) in Costa Rica in 1982 to that in 1988?
Your answer should be compact. 0.57. What is the ratio of the Trade (in US$) of Thailand in 1982 to that in 1988?
Keep it short and to the point. 0.42. What is the ratio of the Trade (in US$) in Sub-Saharan Africa (developing only) in 1983 to that in 1984?
Give a very brief answer. 1.02. What is the ratio of the Trade (in US$) of Burundi in 1983 to that in 1984?
Offer a terse response. 1.15. What is the ratio of the Trade (in US$) of Thailand in 1983 to that in 1984?
Offer a terse response. 1. What is the ratio of the Trade (in US$) of Sub-Saharan Africa (developing only) in 1983 to that in 1985?
Give a very brief answer. 1.13. What is the ratio of the Trade (in US$) of Burundi in 1983 to that in 1985?
Offer a terse response. 1.12. What is the ratio of the Trade (in US$) in Costa Rica in 1983 to that in 1985?
Provide a succinct answer. 0.89. What is the ratio of the Trade (in US$) in Thailand in 1983 to that in 1985?
Your response must be concise. 1.08. What is the ratio of the Trade (in US$) of Sub-Saharan Africa (developing only) in 1983 to that in 1986?
Your response must be concise. 1.04. What is the ratio of the Trade (in US$) of Costa Rica in 1983 to that in 1986?
Keep it short and to the point. 0.83. What is the ratio of the Trade (in US$) in Thailand in 1983 to that in 1986?
Give a very brief answer. 1.08. What is the ratio of the Trade (in US$) in Sub-Saharan Africa (developing only) in 1983 to that in 1987?
Your answer should be compact. 0.88. What is the ratio of the Trade (in US$) of Burundi in 1983 to that in 1987?
Ensure brevity in your answer.  0.92. What is the ratio of the Trade (in US$) of Costa Rica in 1983 to that in 1987?
Offer a very short reply. 0.68. What is the ratio of the Trade (in US$) of Thailand in 1983 to that in 1987?
Provide a succinct answer. 0.76. What is the ratio of the Trade (in US$) of Sub-Saharan Africa (developing only) in 1983 to that in 1988?
Make the answer very short. 0.82. What is the ratio of the Trade (in US$) of Burundi in 1983 to that in 1988?
Keep it short and to the point. 0.95. What is the ratio of the Trade (in US$) of Costa Rica in 1983 to that in 1988?
Your answer should be compact. 0.64. What is the ratio of the Trade (in US$) of Thailand in 1983 to that in 1988?
Your answer should be very brief. 0.51. What is the ratio of the Trade (in US$) in Sub-Saharan Africa (developing only) in 1984 to that in 1985?
Provide a succinct answer. 1.11. What is the ratio of the Trade (in US$) in Burundi in 1984 to that in 1985?
Provide a succinct answer. 0.97. What is the ratio of the Trade (in US$) of Costa Rica in 1984 to that in 1985?
Offer a very short reply. 0.97. What is the ratio of the Trade (in US$) in Thailand in 1984 to that in 1985?
Make the answer very short. 1.08. What is the ratio of the Trade (in US$) of Sub-Saharan Africa (developing only) in 1984 to that in 1986?
Offer a very short reply. 1.02. What is the ratio of the Trade (in US$) in Burundi in 1984 to that in 1986?
Provide a succinct answer. 0.87. What is the ratio of the Trade (in US$) in Costa Rica in 1984 to that in 1986?
Offer a very short reply. 0.9. What is the ratio of the Trade (in US$) of Thailand in 1984 to that in 1986?
Your answer should be compact. 1.08. What is the ratio of the Trade (in US$) of Sub-Saharan Africa (developing only) in 1984 to that in 1987?
Your answer should be compact. 0.86. What is the ratio of the Trade (in US$) in Burundi in 1984 to that in 1987?
Keep it short and to the point. 0.8. What is the ratio of the Trade (in US$) in Costa Rica in 1984 to that in 1987?
Keep it short and to the point. 0.74. What is the ratio of the Trade (in US$) of Thailand in 1984 to that in 1987?
Your answer should be very brief. 0.76. What is the ratio of the Trade (in US$) in Sub-Saharan Africa (developing only) in 1984 to that in 1988?
Give a very brief answer. 0.81. What is the ratio of the Trade (in US$) of Burundi in 1984 to that in 1988?
Your answer should be compact. 0.83. What is the ratio of the Trade (in US$) of Costa Rica in 1984 to that in 1988?
Your answer should be compact. 0.7. What is the ratio of the Trade (in US$) in Thailand in 1984 to that in 1988?
Give a very brief answer. 0.52. What is the ratio of the Trade (in US$) of Sub-Saharan Africa (developing only) in 1985 to that in 1986?
Ensure brevity in your answer.  0.92. What is the ratio of the Trade (in US$) of Burundi in 1985 to that in 1986?
Provide a succinct answer. 0.89. What is the ratio of the Trade (in US$) in Costa Rica in 1985 to that in 1986?
Offer a terse response. 0.93. What is the ratio of the Trade (in US$) of Sub-Saharan Africa (developing only) in 1985 to that in 1987?
Provide a short and direct response. 0.78. What is the ratio of the Trade (in US$) of Burundi in 1985 to that in 1987?
Provide a succinct answer. 0.82. What is the ratio of the Trade (in US$) in Costa Rica in 1985 to that in 1987?
Your answer should be very brief. 0.77. What is the ratio of the Trade (in US$) in Thailand in 1985 to that in 1987?
Offer a terse response. 0.7. What is the ratio of the Trade (in US$) of Sub-Saharan Africa (developing only) in 1985 to that in 1988?
Make the answer very short. 0.73. What is the ratio of the Trade (in US$) of Burundi in 1985 to that in 1988?
Offer a terse response. 0.85. What is the ratio of the Trade (in US$) in Costa Rica in 1985 to that in 1988?
Provide a short and direct response. 0.72. What is the ratio of the Trade (in US$) of Thailand in 1985 to that in 1988?
Give a very brief answer. 0.48. What is the ratio of the Trade (in US$) in Sub-Saharan Africa (developing only) in 1986 to that in 1987?
Offer a terse response. 0.85. What is the ratio of the Trade (in US$) of Burundi in 1986 to that in 1987?
Offer a very short reply. 0.92. What is the ratio of the Trade (in US$) in Costa Rica in 1986 to that in 1987?
Provide a succinct answer. 0.82. What is the ratio of the Trade (in US$) of Thailand in 1986 to that in 1987?
Make the answer very short. 0.71. What is the ratio of the Trade (in US$) in Sub-Saharan Africa (developing only) in 1986 to that in 1988?
Offer a terse response. 0.79. What is the ratio of the Trade (in US$) in Burundi in 1986 to that in 1988?
Your response must be concise. 0.95. What is the ratio of the Trade (in US$) of Costa Rica in 1986 to that in 1988?
Make the answer very short. 0.77. What is the ratio of the Trade (in US$) of Thailand in 1986 to that in 1988?
Give a very brief answer. 0.48. What is the ratio of the Trade (in US$) of Sub-Saharan Africa (developing only) in 1987 to that in 1988?
Provide a short and direct response. 0.93. What is the ratio of the Trade (in US$) in Burundi in 1987 to that in 1988?
Ensure brevity in your answer.  1.04. What is the ratio of the Trade (in US$) in Costa Rica in 1987 to that in 1988?
Make the answer very short. 0.94. What is the ratio of the Trade (in US$) in Thailand in 1987 to that in 1988?
Ensure brevity in your answer.  0.67. What is the difference between the highest and the second highest Trade (in US$) in Sub-Saharan Africa (developing only)?
Offer a very short reply. 2.08e+09. What is the difference between the highest and the second highest Trade (in US$) of Burundi?
Your response must be concise. 1.03e+07. What is the difference between the highest and the second highest Trade (in US$) in Costa Rica?
Your answer should be compact. 1.19e+08. What is the difference between the highest and the second highest Trade (in US$) in Thailand?
Your answer should be very brief. 6.90e+09. What is the difference between the highest and the lowest Trade (in US$) of Sub-Saharan Africa (developing only)?
Your response must be concise. 2.13e+1. What is the difference between the highest and the lowest Trade (in US$) of Burundi?
Offer a terse response. 5.87e+07. What is the difference between the highest and the lowest Trade (in US$) of Costa Rica?
Your answer should be compact. 8.15e+08. What is the difference between the highest and the lowest Trade (in US$) of Thailand?
Your answer should be compact. 1.22e+1. 